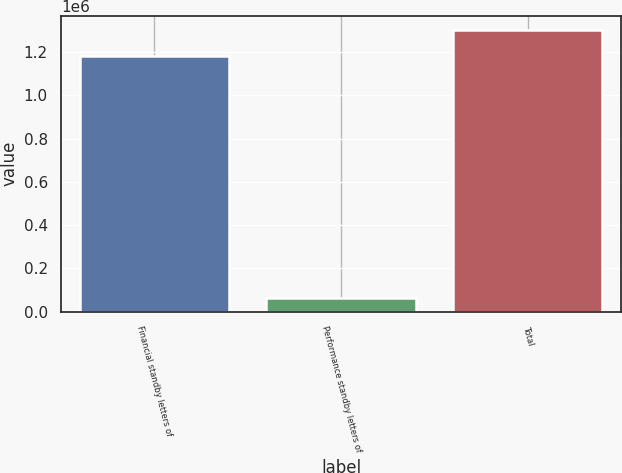Convert chart. <chart><loc_0><loc_0><loc_500><loc_500><bar_chart><fcel>Financial standby letters of<fcel>Performance standby letters of<fcel>Total<nl><fcel>1.18388e+06<fcel>64191<fcel>1.3029e+06<nl></chart> 